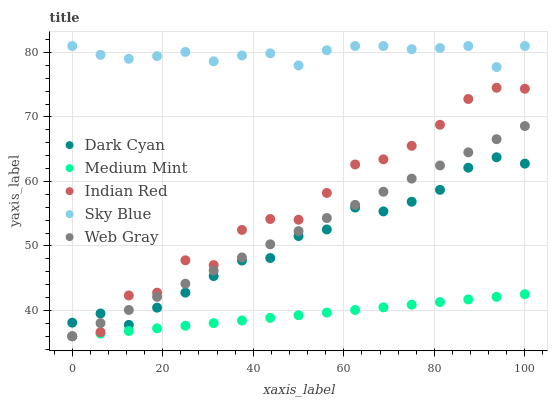Does Medium Mint have the minimum area under the curve?
Answer yes or no. Yes. Does Sky Blue have the maximum area under the curve?
Answer yes or no. Yes. Does Web Gray have the minimum area under the curve?
Answer yes or no. No. Does Web Gray have the maximum area under the curve?
Answer yes or no. No. Is Medium Mint the smoothest?
Answer yes or no. Yes. Is Indian Red the roughest?
Answer yes or no. Yes. Is Web Gray the smoothest?
Answer yes or no. No. Is Web Gray the roughest?
Answer yes or no. No. Does Medium Mint have the lowest value?
Answer yes or no. Yes. Does Sky Blue have the lowest value?
Answer yes or no. No. Does Sky Blue have the highest value?
Answer yes or no. Yes. Does Web Gray have the highest value?
Answer yes or no. No. Is Medium Mint less than Dark Cyan?
Answer yes or no. Yes. Is Dark Cyan greater than Medium Mint?
Answer yes or no. Yes. Does Indian Red intersect Dark Cyan?
Answer yes or no. Yes. Is Indian Red less than Dark Cyan?
Answer yes or no. No. Is Indian Red greater than Dark Cyan?
Answer yes or no. No. Does Medium Mint intersect Dark Cyan?
Answer yes or no. No. 